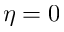<formula> <loc_0><loc_0><loc_500><loc_500>\eta = 0</formula> 